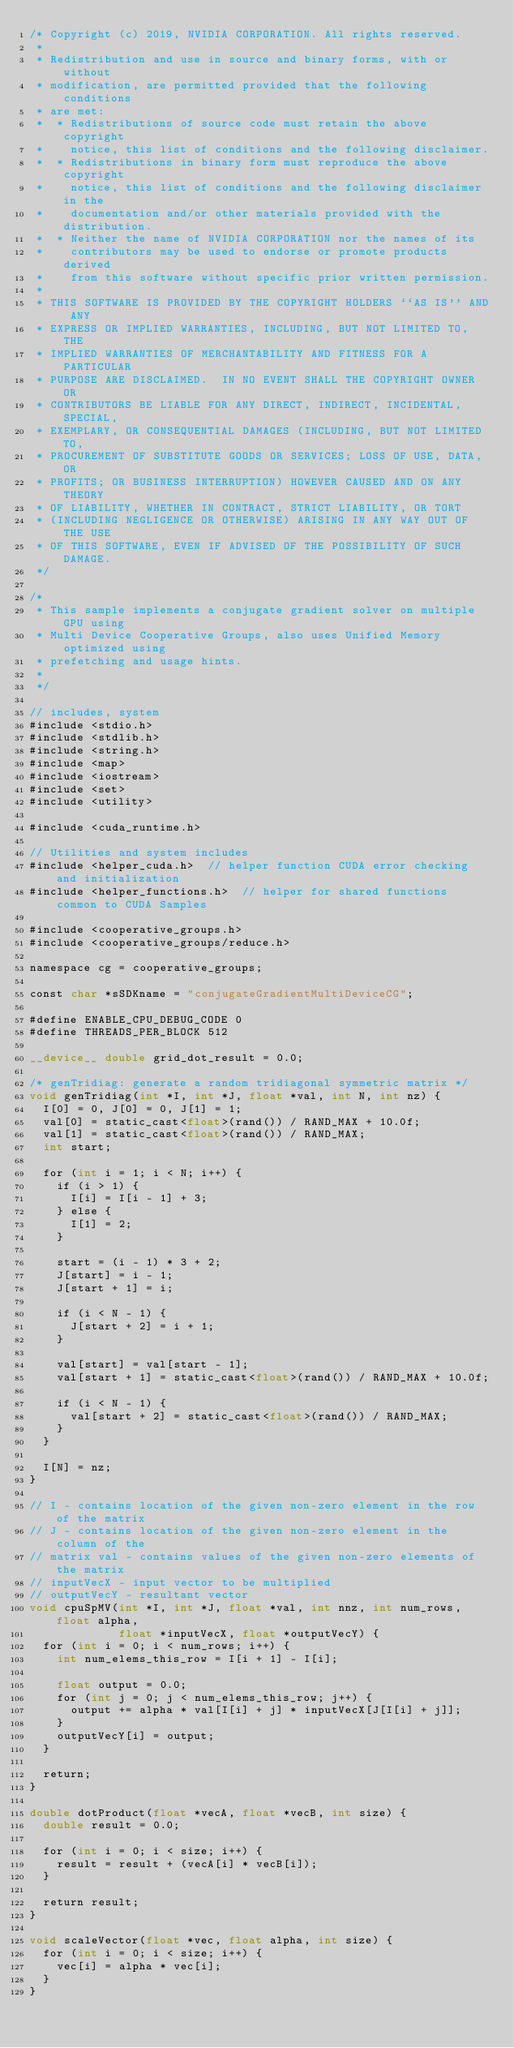<code> <loc_0><loc_0><loc_500><loc_500><_Cuda_>/* Copyright (c) 2019, NVIDIA CORPORATION. All rights reserved.
 *
 * Redistribution and use in source and binary forms, with or without
 * modification, are permitted provided that the following conditions
 * are met:
 *  * Redistributions of source code must retain the above copyright
 *    notice, this list of conditions and the following disclaimer.
 *  * Redistributions in binary form must reproduce the above copyright
 *    notice, this list of conditions and the following disclaimer in the
 *    documentation and/or other materials provided with the distribution.
 *  * Neither the name of NVIDIA CORPORATION nor the names of its
 *    contributors may be used to endorse or promote products derived
 *    from this software without specific prior written permission.
 *
 * THIS SOFTWARE IS PROVIDED BY THE COPYRIGHT HOLDERS ``AS IS'' AND ANY
 * EXPRESS OR IMPLIED WARRANTIES, INCLUDING, BUT NOT LIMITED TO, THE
 * IMPLIED WARRANTIES OF MERCHANTABILITY AND FITNESS FOR A PARTICULAR
 * PURPOSE ARE DISCLAIMED.  IN NO EVENT SHALL THE COPYRIGHT OWNER OR
 * CONTRIBUTORS BE LIABLE FOR ANY DIRECT, INDIRECT, INCIDENTAL, SPECIAL,
 * EXEMPLARY, OR CONSEQUENTIAL DAMAGES (INCLUDING, BUT NOT LIMITED TO,
 * PROCUREMENT OF SUBSTITUTE GOODS OR SERVICES; LOSS OF USE, DATA, OR
 * PROFITS; OR BUSINESS INTERRUPTION) HOWEVER CAUSED AND ON ANY THEORY
 * OF LIABILITY, WHETHER IN CONTRACT, STRICT LIABILITY, OR TORT
 * (INCLUDING NEGLIGENCE OR OTHERWISE) ARISING IN ANY WAY OUT OF THE USE
 * OF THIS SOFTWARE, EVEN IF ADVISED OF THE POSSIBILITY OF SUCH DAMAGE.
 */

/*
 * This sample implements a conjugate gradient solver on multiple GPU using
 * Multi Device Cooperative Groups, also uses Unified Memory optimized using
 * prefetching and usage hints.
 *
 */

// includes, system
#include <stdio.h>
#include <stdlib.h>
#include <string.h>
#include <map>
#include <iostream>
#include <set>
#include <utility>

#include <cuda_runtime.h>

// Utilities and system includes
#include <helper_cuda.h>  // helper function CUDA error checking and initialization
#include <helper_functions.h>  // helper for shared functions common to CUDA Samples

#include <cooperative_groups.h>
#include <cooperative_groups/reduce.h>

namespace cg = cooperative_groups;

const char *sSDKname = "conjugateGradientMultiDeviceCG";

#define ENABLE_CPU_DEBUG_CODE 0
#define THREADS_PER_BLOCK 512

__device__ double grid_dot_result = 0.0;

/* genTridiag: generate a random tridiagonal symmetric matrix */
void genTridiag(int *I, int *J, float *val, int N, int nz) {
  I[0] = 0, J[0] = 0, J[1] = 1;
  val[0] = static_cast<float>(rand()) / RAND_MAX + 10.0f;
  val[1] = static_cast<float>(rand()) / RAND_MAX;
  int start;

  for (int i = 1; i < N; i++) {
    if (i > 1) {
      I[i] = I[i - 1] + 3;
    } else {
      I[1] = 2;
    }

    start = (i - 1) * 3 + 2;
    J[start] = i - 1;
    J[start + 1] = i;

    if (i < N - 1) {
      J[start + 2] = i + 1;
    }

    val[start] = val[start - 1];
    val[start + 1] = static_cast<float>(rand()) / RAND_MAX + 10.0f;

    if (i < N - 1) {
      val[start + 2] = static_cast<float>(rand()) / RAND_MAX;
    }
  }

  I[N] = nz;
}

// I - contains location of the given non-zero element in the row of the matrix
// J - contains location of the given non-zero element in the column of the
// matrix val - contains values of the given non-zero elements of the matrix
// inputVecX - input vector to be multiplied
// outputVecY - resultant vector
void cpuSpMV(int *I, int *J, float *val, int nnz, int num_rows, float alpha,
             float *inputVecX, float *outputVecY) {
  for (int i = 0; i < num_rows; i++) {
    int num_elems_this_row = I[i + 1] - I[i];

    float output = 0.0;
    for (int j = 0; j < num_elems_this_row; j++) {
      output += alpha * val[I[i] + j] * inputVecX[J[I[i] + j]];
    }
    outputVecY[i] = output;
  }

  return;
}

double dotProduct(float *vecA, float *vecB, int size) {
  double result = 0.0;

  for (int i = 0; i < size; i++) {
    result = result + (vecA[i] * vecB[i]);
  }

  return result;
}

void scaleVector(float *vec, float alpha, int size) {
  for (int i = 0; i < size; i++) {
    vec[i] = alpha * vec[i];
  }
}
</code> 